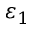<formula> <loc_0><loc_0><loc_500><loc_500>\varepsilon _ { 1 }</formula> 